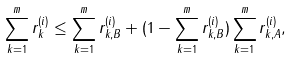Convert formula to latex. <formula><loc_0><loc_0><loc_500><loc_500>\sum _ { k = 1 } ^ { m } r _ { k } ^ { ( i ) } \leq \sum _ { k = 1 } ^ { m } r _ { k , B } ^ { ( i ) } + ( 1 - \sum _ { k = 1 } ^ { m } r _ { k , B } ^ { ( i ) } ) \sum _ { k = 1 } ^ { m } r _ { k , A } ^ { ( i ) } ,</formula> 